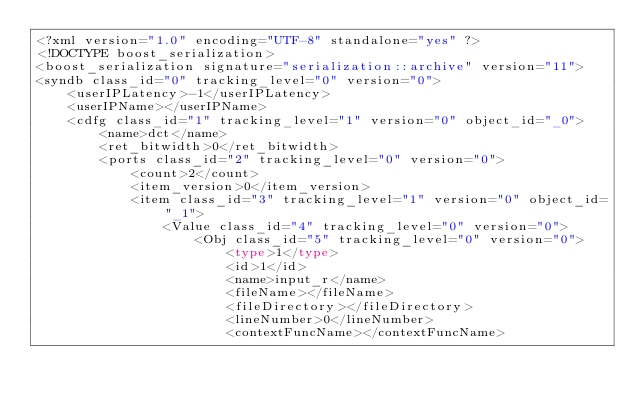Convert code to text. <code><loc_0><loc_0><loc_500><loc_500><_Ada_><?xml version="1.0" encoding="UTF-8" standalone="yes" ?>
<!DOCTYPE boost_serialization>
<boost_serialization signature="serialization::archive" version="11">
<syndb class_id="0" tracking_level="0" version="0">
	<userIPLatency>-1</userIPLatency>
	<userIPName></userIPName>
	<cdfg class_id="1" tracking_level="1" version="0" object_id="_0">
		<name>dct</name>
		<ret_bitwidth>0</ret_bitwidth>
		<ports class_id="2" tracking_level="0" version="0">
			<count>2</count>
			<item_version>0</item_version>
			<item class_id="3" tracking_level="1" version="0" object_id="_1">
				<Value class_id="4" tracking_level="0" version="0">
					<Obj class_id="5" tracking_level="0" version="0">
						<type>1</type>
						<id>1</id>
						<name>input_r</name>
						<fileName></fileName>
						<fileDirectory></fileDirectory>
						<lineNumber>0</lineNumber>
						<contextFuncName></contextFuncName></code> 